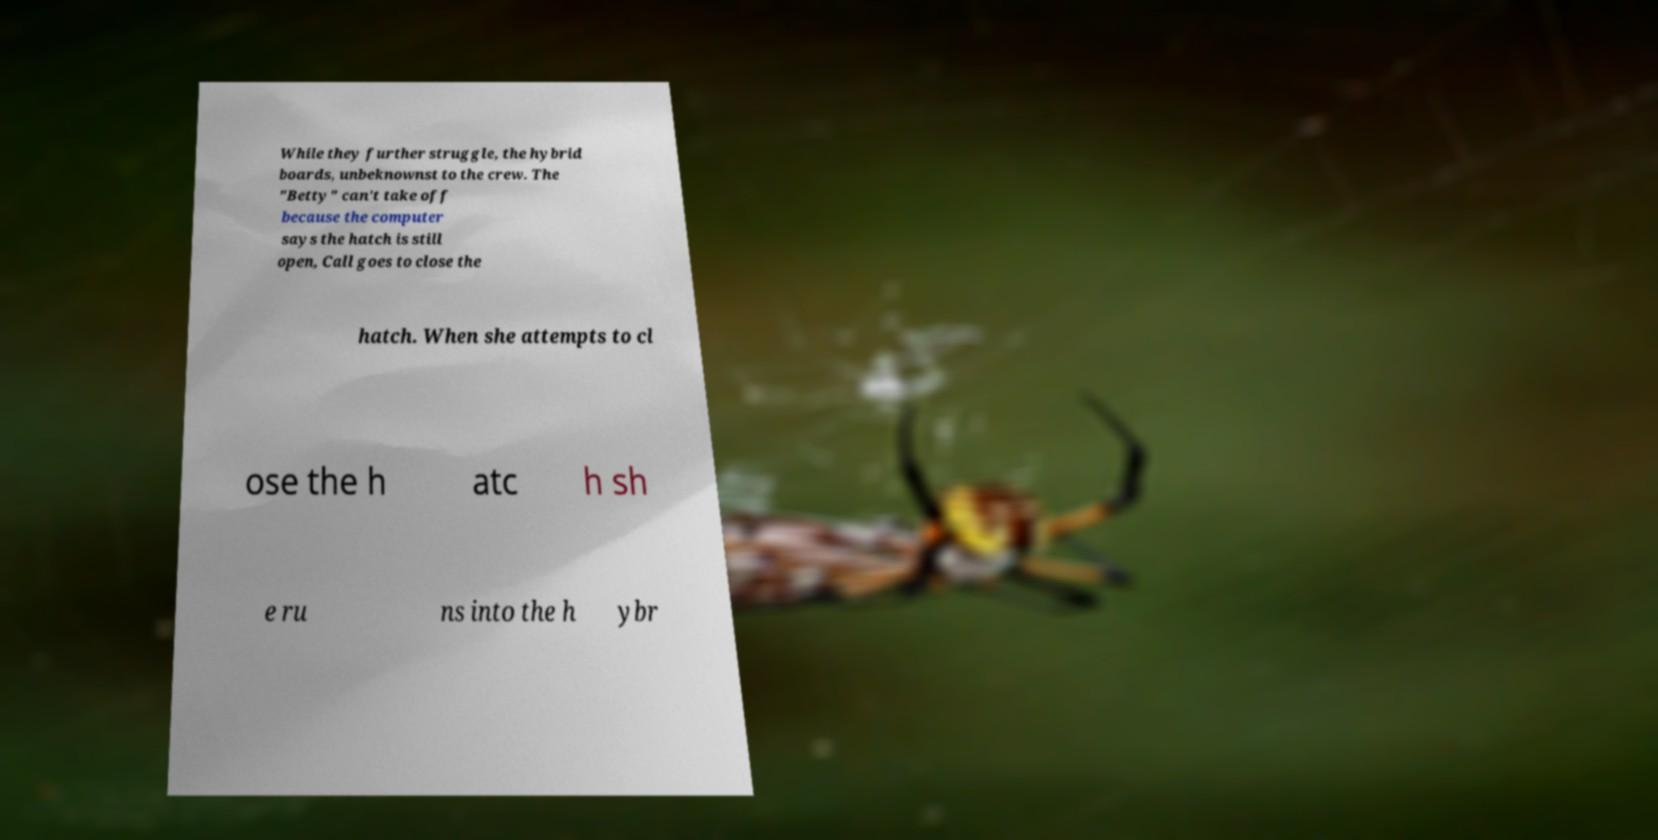There's text embedded in this image that I need extracted. Can you transcribe it verbatim? While they further struggle, the hybrid boards, unbeknownst to the crew. The "Betty" can't take off because the computer says the hatch is still open, Call goes to close the hatch. When she attempts to cl ose the h atc h sh e ru ns into the h ybr 